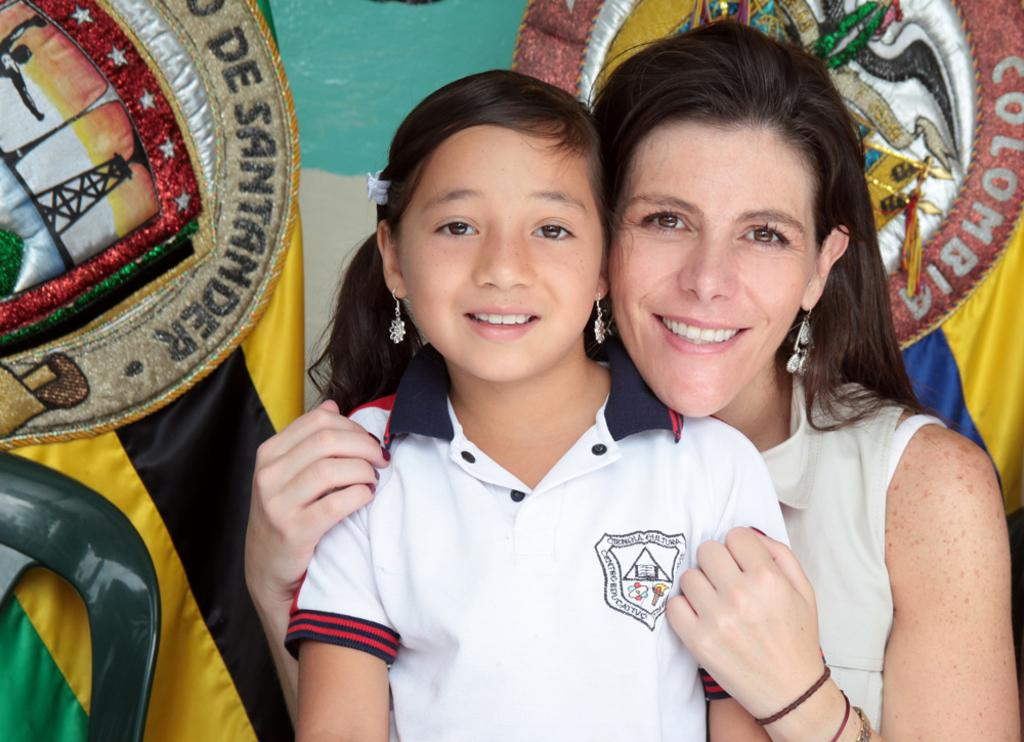Who is present in the image? There is a woman and a child in the image. What are they wearing? The woman is wearing a white dress, and the child is wearing a white T-shirt. What expressions do they have? Both the woman and the child are smiling. What can be seen in the background of the image? There are objects in the background of the image. What type of tools is the carpenter using in the image? There is no carpenter present in the image, and therefore no tools can be observed. Can you tell me how many pigs are visible in the image? There are no pigs present in the image. 